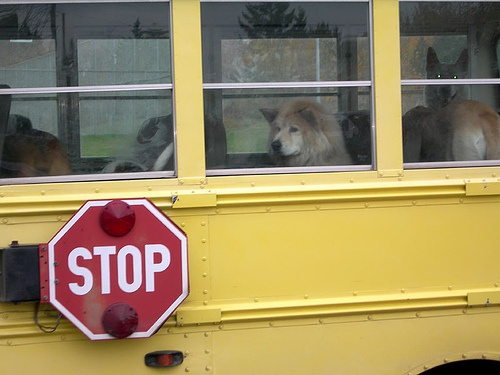Describe the objects in this image and their specific colors. I can see bus in gray, khaki, black, and tan tones, stop sign in gray, brown, lavender, and maroon tones, dog in gray, black, and darkgray tones, dog in gray and black tones, and dog in gray and black tones in this image. 